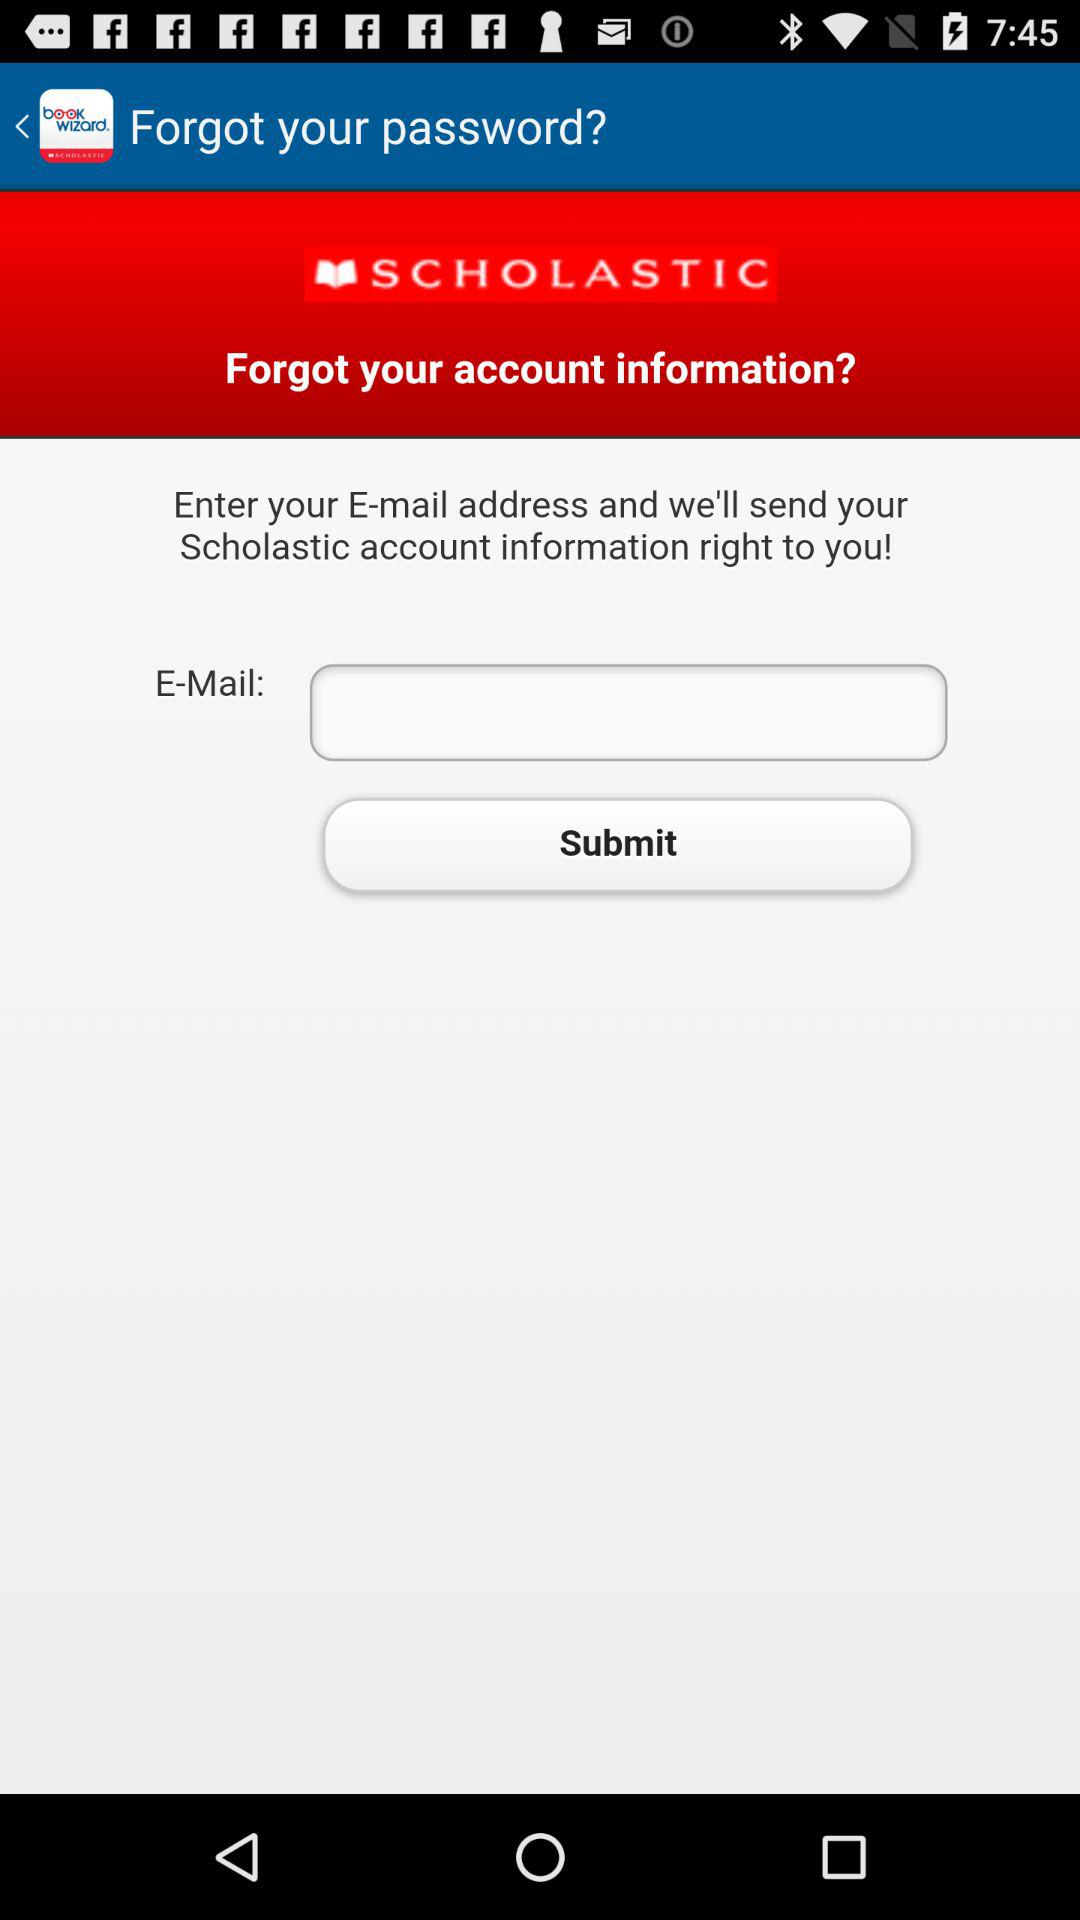What is the entered email address?
When the provided information is insufficient, respond with <no answer>. <no answer> 